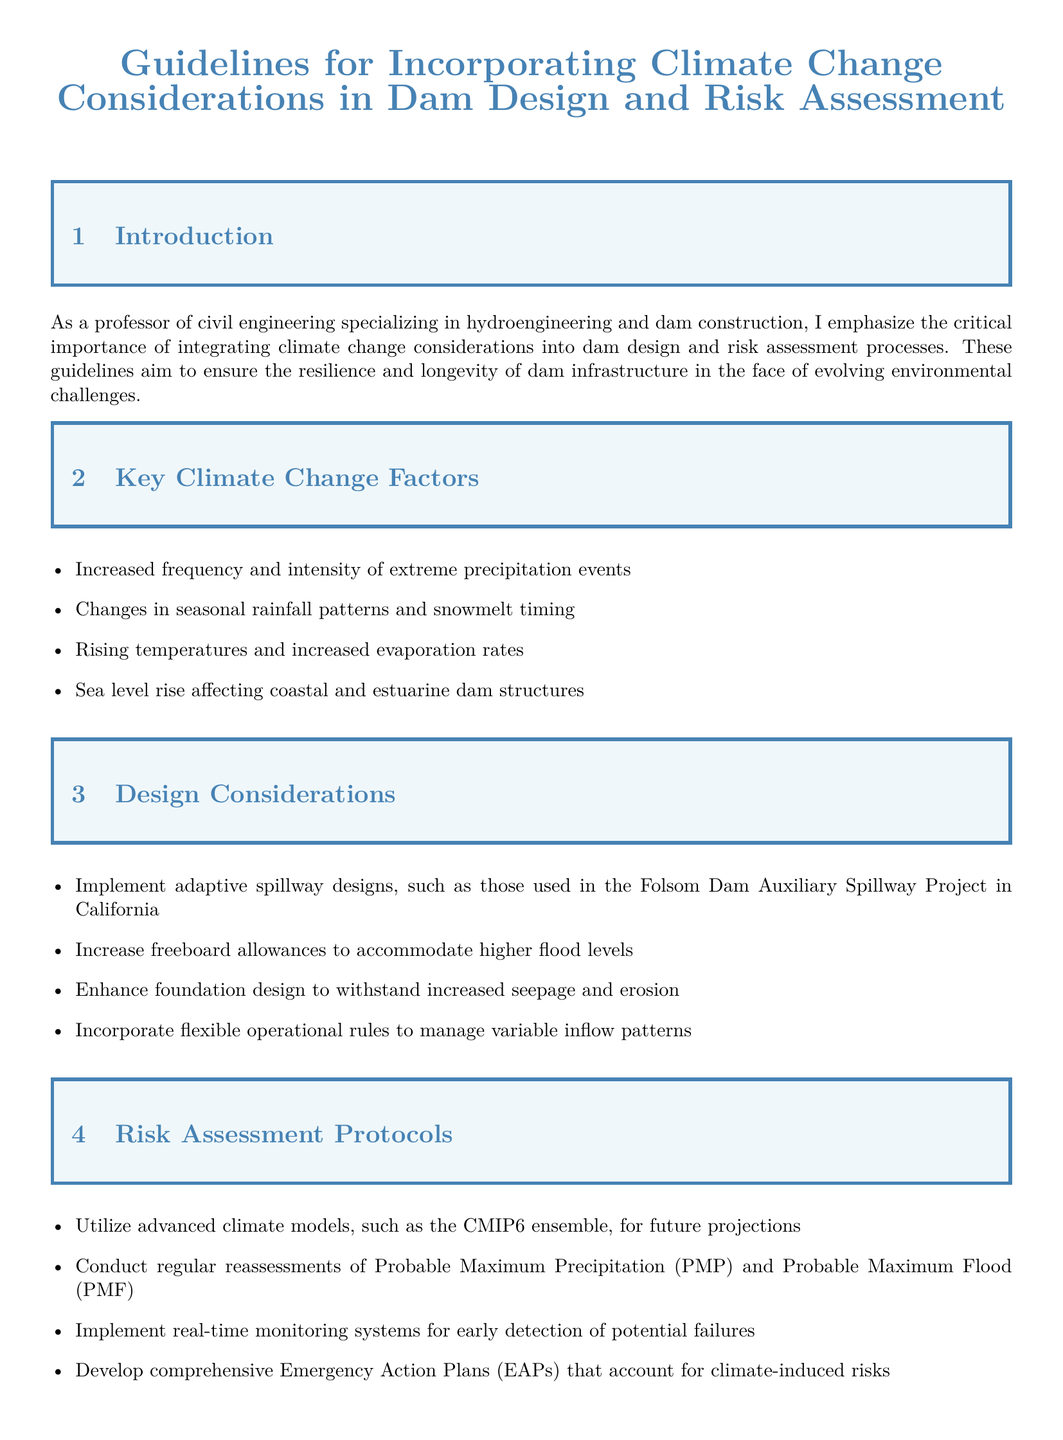What is the title of the document? The title of the document is prominently displayed at the beginning and identifies the main focus.
Answer: Guidelines for Incorporating Climate Change Considerations in Dam Design and Risk Assessment What year did the Oroville Dam incident occur? The specific event highlighted in the case study section indicates when the incident took place.
Answer: 2017 What are the four key climate change factors mentioned? A list in the document outlines the significant factors affecting dam design due to climate change.
Answer: Increased frequency and intensity of extreme precipitation events, Changes in seasonal rainfall patterns and snowmelt timing, Rising temperatures and increased evaporation rates, Sea level rise affecting coastal and estuarine dam structures What is one example of an adaptive spillway design? The document provides a specific project as an example of adaptive design in the context of spillways.
Answer: Folsom Dam Auxiliary Spillway Project What does the term "EAP" stand for? The document mentions these short terms, which are specific to emergency guidelines in dam management.
Answer: Emergency Action Plans What does PMF stand for in the context of risk assessment? The document uses this term when discussing flood risk, giving a precise definition in the context of dam assessments.
Answer: Probable Maximum Flood Why is it important to incorporate climate change considerations in dam design? The introduction and conclusion sections convey the overarching importance of this integration for infrastructure longevity.
Answer: To ensure the safety, efficiency, and longevity of water infrastructure What major risk does the Oroville Dam incident illustrate? The case study point out a crucial challenge faced in dam engineering that emerged from a real incident.
Answer: Climate-resilient infrastructure What is recommended for real-time monitoring? The risk assessment section specifies the type of systems that should be used for monitoring dam conditions.
Answer: Real-time monitoring systems for early detection of potential failures 